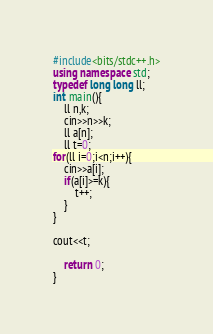Convert code to text. <code><loc_0><loc_0><loc_500><loc_500><_C++_>#include<bits/stdc++.h>
using namespace std;
typedef long long ll;
int main(){
	ll n,k;
	cin>>n>>k;
	ll a[n];
	ll t=0;
for(ll i=0;i<n;i++){
	cin>>a[i];
	if(a[i]>=k){
		t++;
	}
}

cout<<t;
	
	return 0;
}</code> 